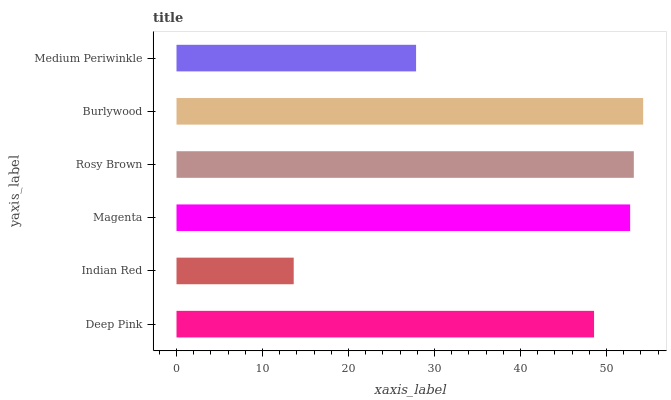Is Indian Red the minimum?
Answer yes or no. Yes. Is Burlywood the maximum?
Answer yes or no. Yes. Is Magenta the minimum?
Answer yes or no. No. Is Magenta the maximum?
Answer yes or no. No. Is Magenta greater than Indian Red?
Answer yes or no. Yes. Is Indian Red less than Magenta?
Answer yes or no. Yes. Is Indian Red greater than Magenta?
Answer yes or no. No. Is Magenta less than Indian Red?
Answer yes or no. No. Is Magenta the high median?
Answer yes or no. Yes. Is Deep Pink the low median?
Answer yes or no. Yes. Is Medium Periwinkle the high median?
Answer yes or no. No. Is Burlywood the low median?
Answer yes or no. No. 